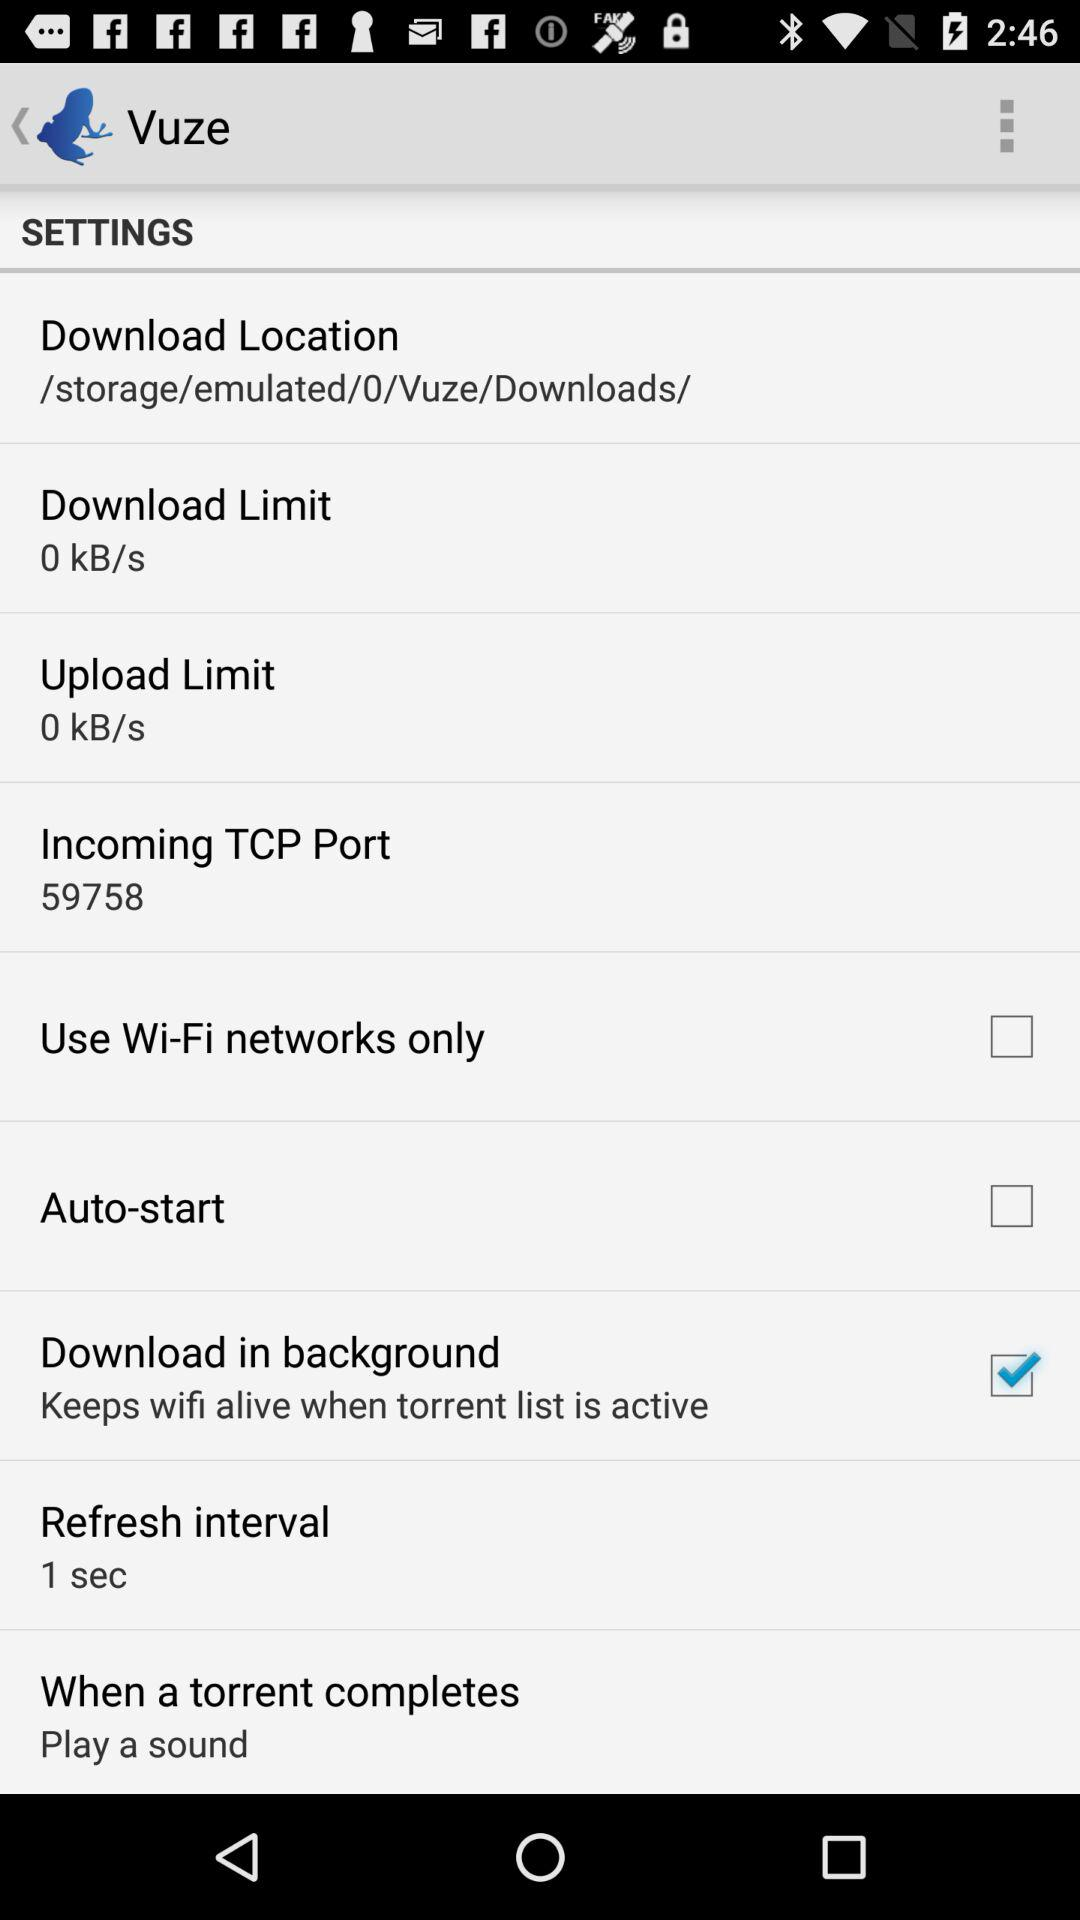What is the name of the application? The name of the application is "Vuze". 